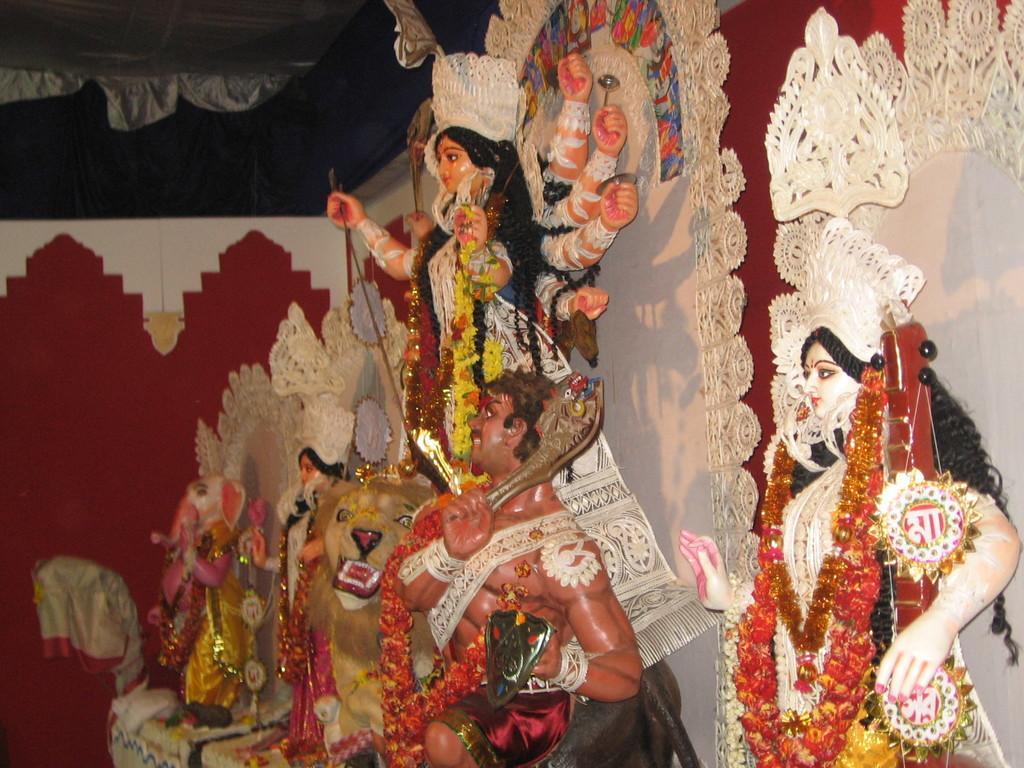How would you summarize this image in a sentence or two? In this pictures there are statues of gods and goddess. The statues are decorated with the clothes and garlands. On the top, there are tents. 